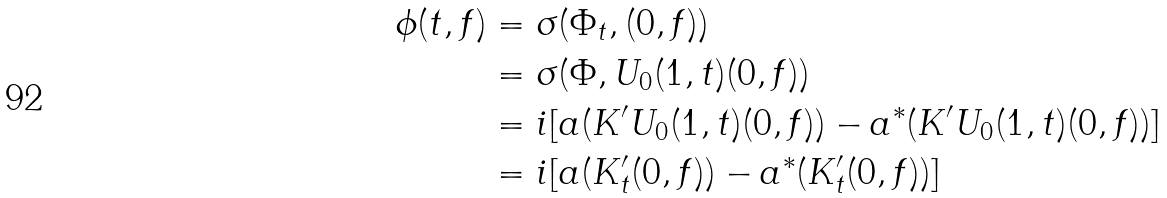Convert formula to latex. <formula><loc_0><loc_0><loc_500><loc_500>\phi ( t , f ) & = \sigma ( \Phi _ { t } , ( 0 , f ) ) \\ & = \sigma ( \Phi , U _ { 0 } ( 1 , t ) ( 0 , f ) ) \\ & = i [ a ( K ^ { \prime } U _ { 0 } ( 1 , t ) ( 0 , f ) ) - a ^ { * } ( K ^ { \prime } U _ { 0 } ( 1 , t ) ( 0 , f ) ) ] \\ & = i [ a ( K _ { t } ^ { \prime } ( 0 , f ) ) - a ^ { * } ( K _ { t } ^ { \prime } ( 0 , f ) ) ]</formula> 